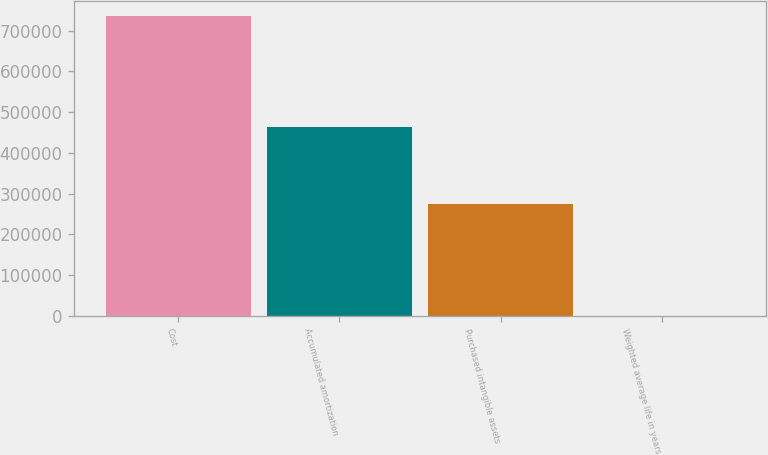Convert chart to OTSL. <chart><loc_0><loc_0><loc_500><loc_500><bar_chart><fcel>Cost<fcel>Accumulated amortization<fcel>Purchased intangible assets<fcel>Weighted average life in years<nl><fcel>736163<fcel>463076<fcel>273087<fcel>4<nl></chart> 